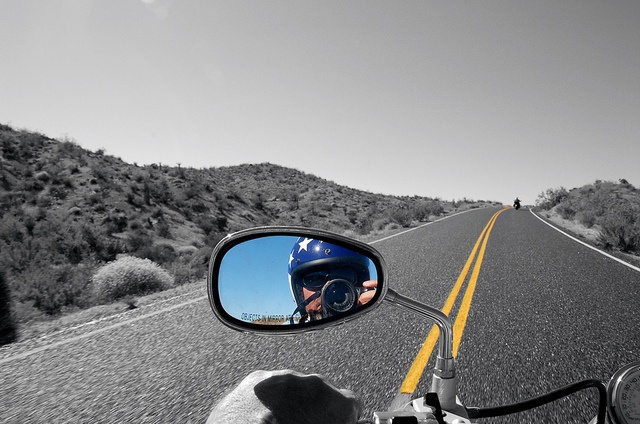Describe the objects in this image and their specific colors. I can see motorcycle in lightgray, black, gray, lightblue, and darkgray tones, people in lightgray, black, navy, blue, and gray tones, people in lightgray, black, gray, and darkgray tones, and motorcycle in lightgray, black, gray, and darkgray tones in this image. 